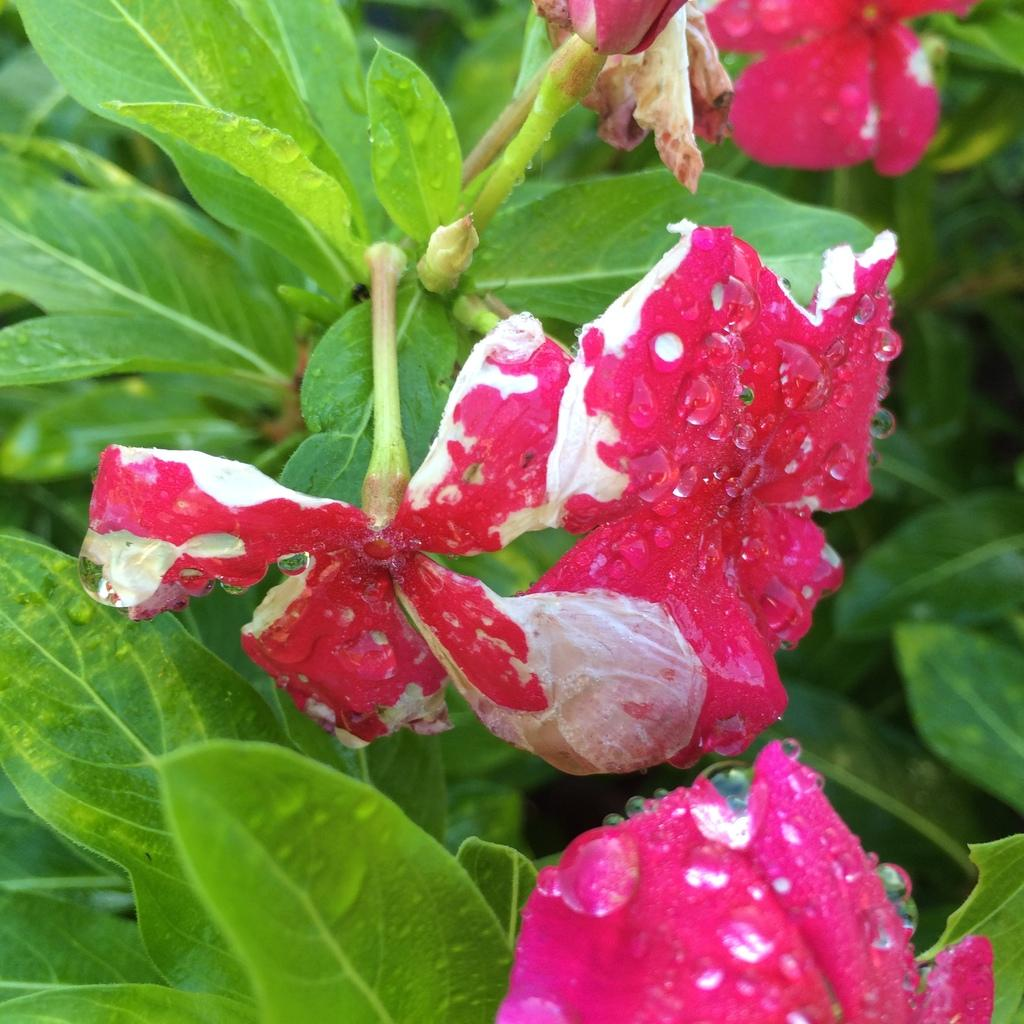What color are the flowers in the image? The flowers in the image are pink. What are the flowers growing on? The flowers are on plants. How many frogs can be seen sitting on the popcorn in the image? There are no frogs or popcorn present in the image; it features pink color flowers on plants. 